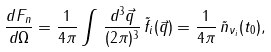Convert formula to latex. <formula><loc_0><loc_0><loc_500><loc_500>\frac { d F _ { n } } { d \Omega } = \frac { 1 } { 4 \pi } \int \, \frac { d ^ { 3 } \vec { q } } { ( 2 \pi ) ^ { 3 } } \, \tilde { f } _ { i } ( \vec { q } ) = \frac { 1 } { 4 \pi } \, \tilde { n } _ { \nu _ { i } } ( t _ { 0 } ) ,</formula> 